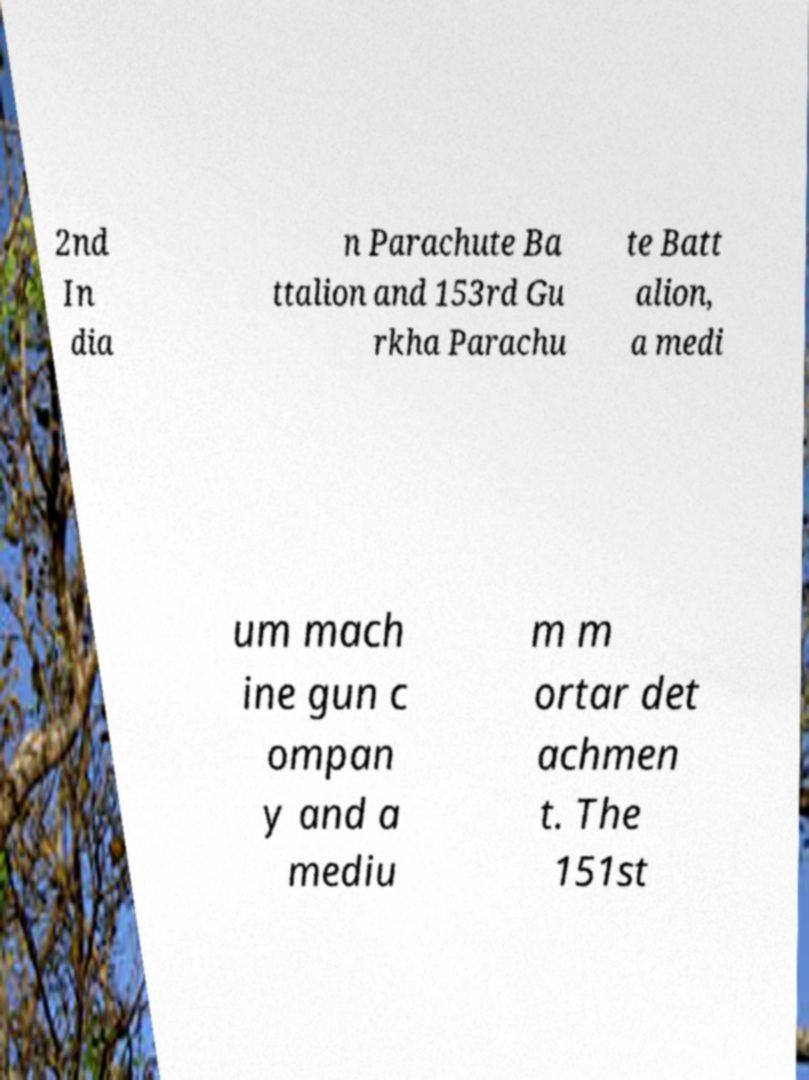There's text embedded in this image that I need extracted. Can you transcribe it verbatim? 2nd In dia n Parachute Ba ttalion and 153rd Gu rkha Parachu te Batt alion, a medi um mach ine gun c ompan y and a mediu m m ortar det achmen t. The 151st 